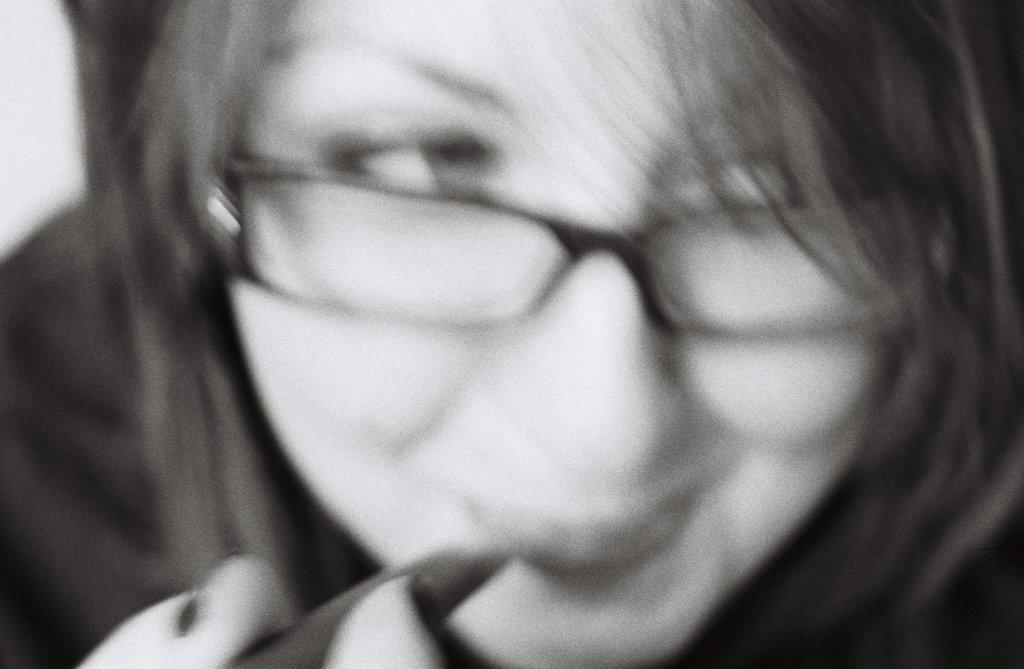What is the main subject of the image? The main subject of the image is a woman's face. What is the woman holding in the image? The woman is holding something in the image. What is the color scheme of the image? The image is black and white. How much is the price of the bridge in the image? There is no bridge present in the image, so it is not possible to determine its price. 